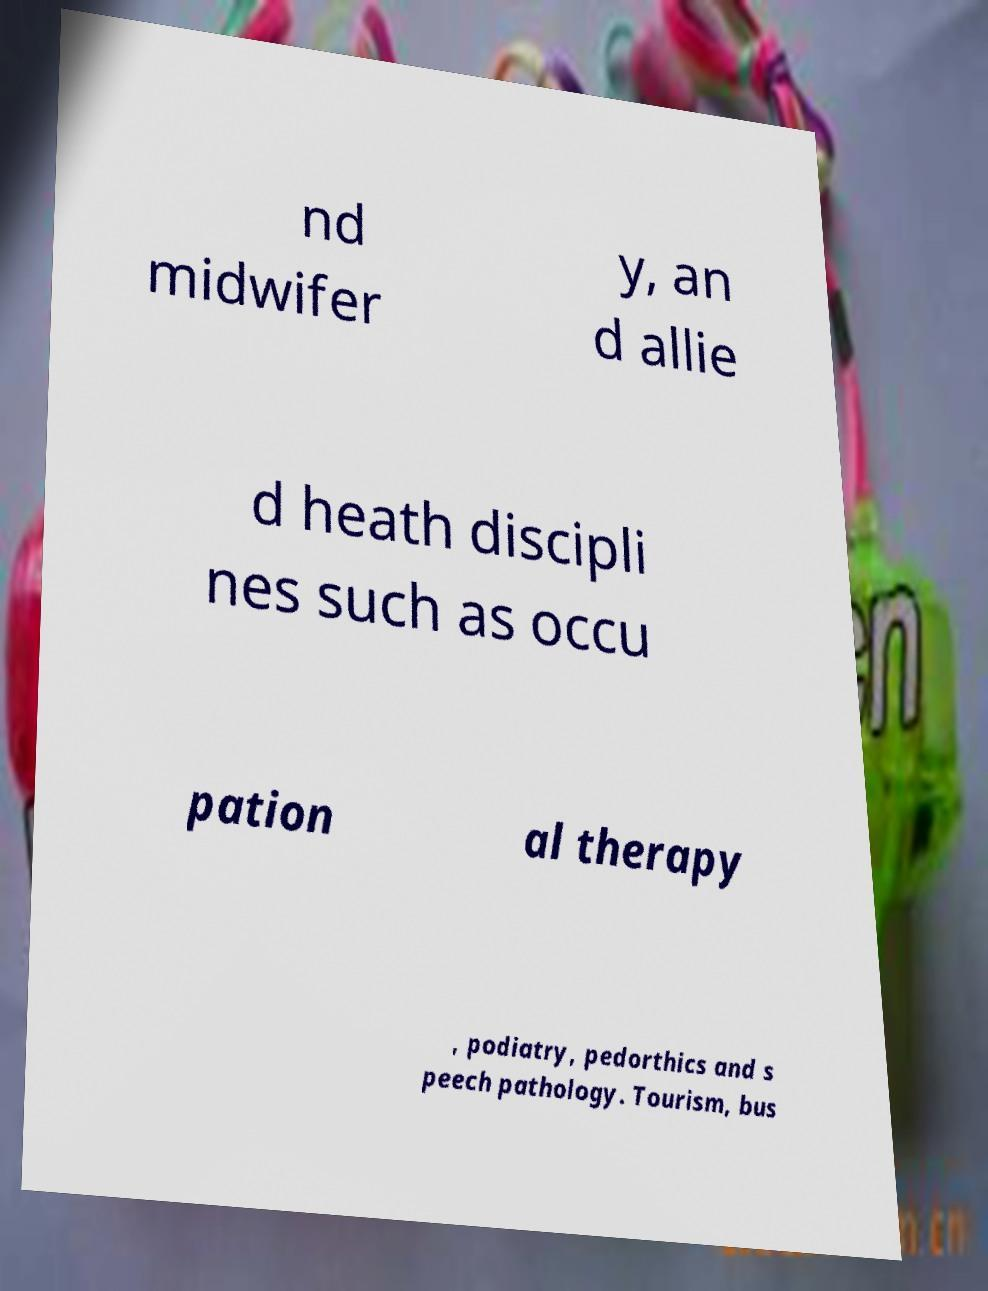Can you accurately transcribe the text from the provided image for me? nd midwifer y, an d allie d heath discipli nes such as occu pation al therapy , podiatry, pedorthics and s peech pathology. Tourism, bus 